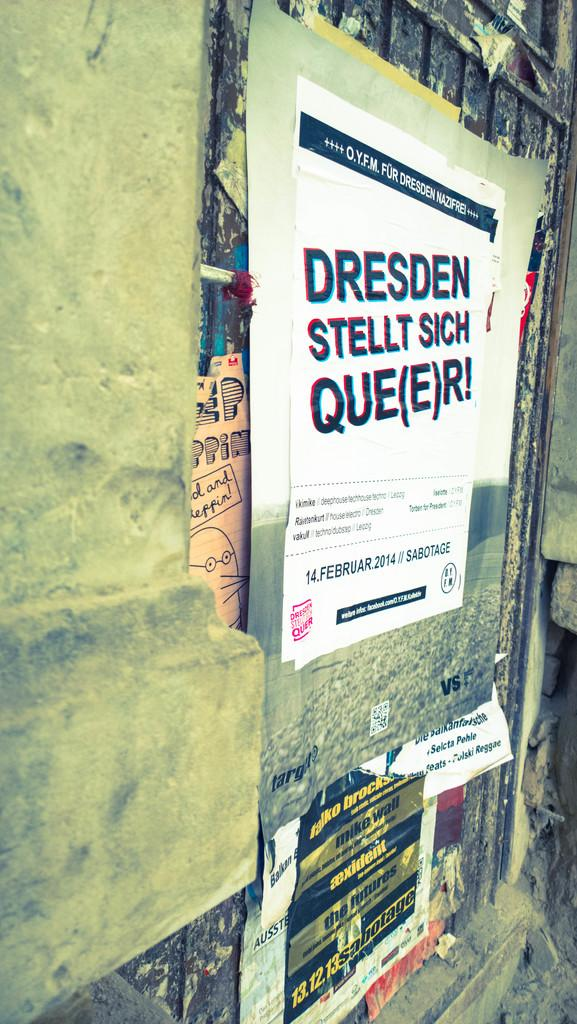<image>
Present a compact description of the photo's key features. Dresden Stellt Sich Que(E)R sign on a bulletin board. 